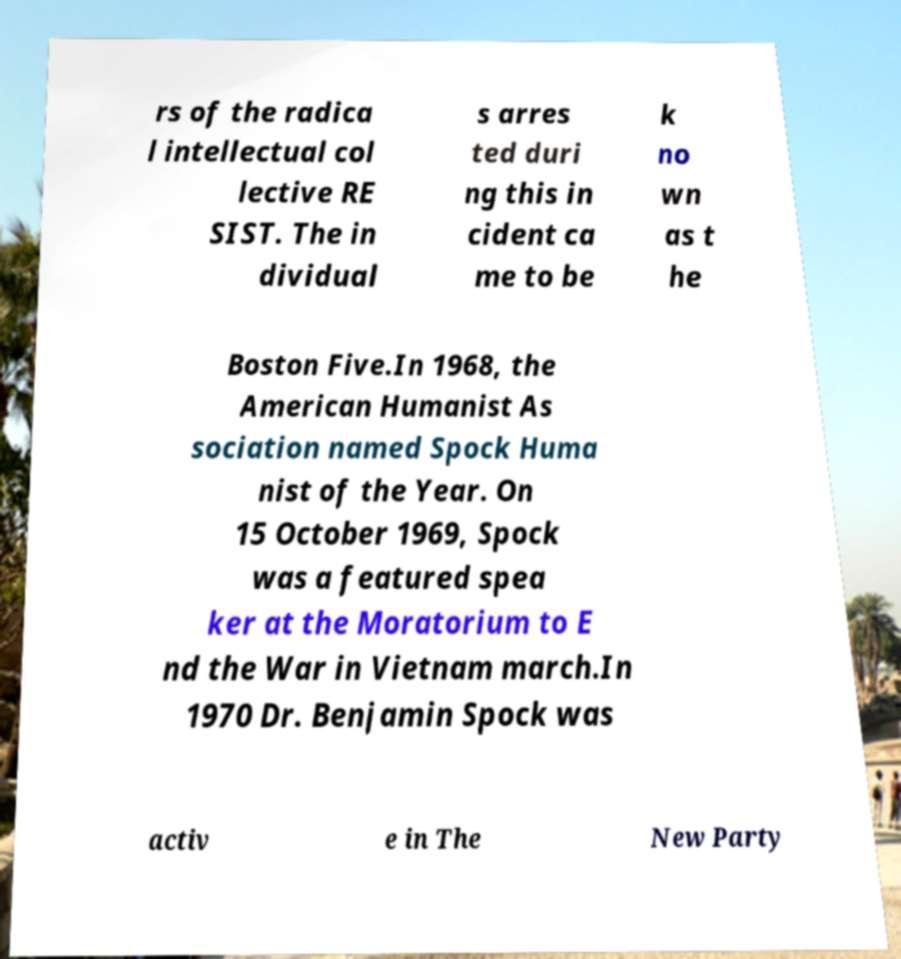Please read and relay the text visible in this image. What does it say? rs of the radica l intellectual col lective RE SIST. The in dividual s arres ted duri ng this in cident ca me to be k no wn as t he Boston Five.In 1968, the American Humanist As sociation named Spock Huma nist of the Year. On 15 October 1969, Spock was a featured spea ker at the Moratorium to E nd the War in Vietnam march.In 1970 Dr. Benjamin Spock was activ e in The New Party 